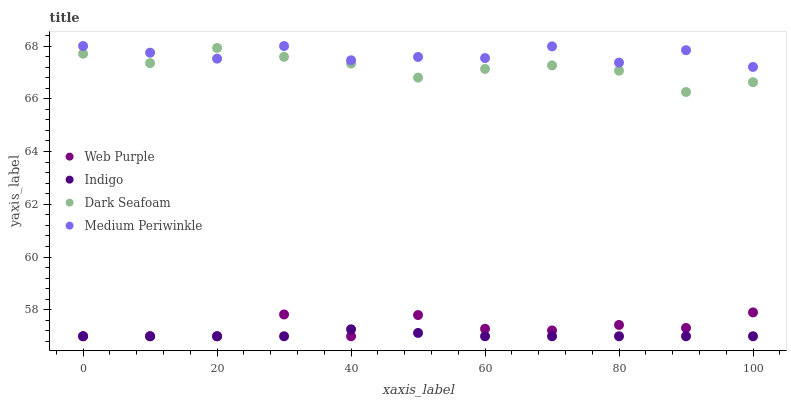Does Indigo have the minimum area under the curve?
Answer yes or no. Yes. Does Medium Periwinkle have the maximum area under the curve?
Answer yes or no. Yes. Does Web Purple have the minimum area under the curve?
Answer yes or no. No. Does Web Purple have the maximum area under the curve?
Answer yes or no. No. Is Indigo the smoothest?
Answer yes or no. Yes. Is Web Purple the roughest?
Answer yes or no. Yes. Is Web Purple the smoothest?
Answer yes or no. No. Is Indigo the roughest?
Answer yes or no. No. Does Web Purple have the lowest value?
Answer yes or no. Yes. Does Dark Seafoam have the lowest value?
Answer yes or no. No. Does Medium Periwinkle have the highest value?
Answer yes or no. Yes. Does Web Purple have the highest value?
Answer yes or no. No. Is Web Purple less than Medium Periwinkle?
Answer yes or no. Yes. Is Dark Seafoam greater than Indigo?
Answer yes or no. Yes. Does Web Purple intersect Indigo?
Answer yes or no. Yes. Is Web Purple less than Indigo?
Answer yes or no. No. Is Web Purple greater than Indigo?
Answer yes or no. No. Does Web Purple intersect Medium Periwinkle?
Answer yes or no. No. 